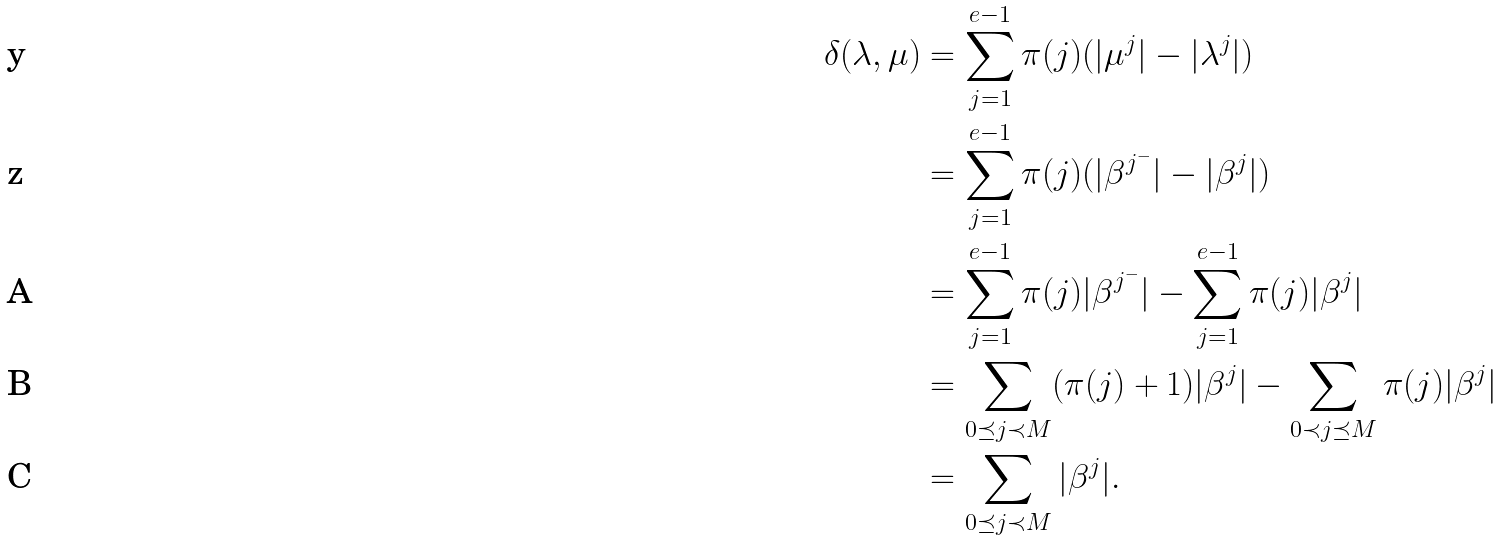Convert formula to latex. <formula><loc_0><loc_0><loc_500><loc_500>\delta ( \lambda , \mu ) & = \sum _ { j = 1 } ^ { e - 1 } \pi ( j ) ( | \mu ^ { j } | - | \lambda ^ { j } | ) \\ & = \sum _ { j = 1 } ^ { e - 1 } \pi ( j ) ( | \beta ^ { j ^ { - } } | - | \beta ^ { j } | ) \\ & = \sum _ { j = 1 } ^ { e - 1 } \pi ( j ) | \beta ^ { j ^ { - } } | - \sum _ { j = 1 } ^ { e - 1 } \pi ( j ) | \beta ^ { j } | \\ & = \sum _ { 0 \preceq j \prec M } ( \pi ( j ) + 1 ) | \beta ^ { j } | - \sum _ { 0 \prec j \preceq M } \pi ( j ) | \beta ^ { j } | \\ & = \sum _ { 0 \preceq j \prec M } | \beta ^ { j } | .</formula> 